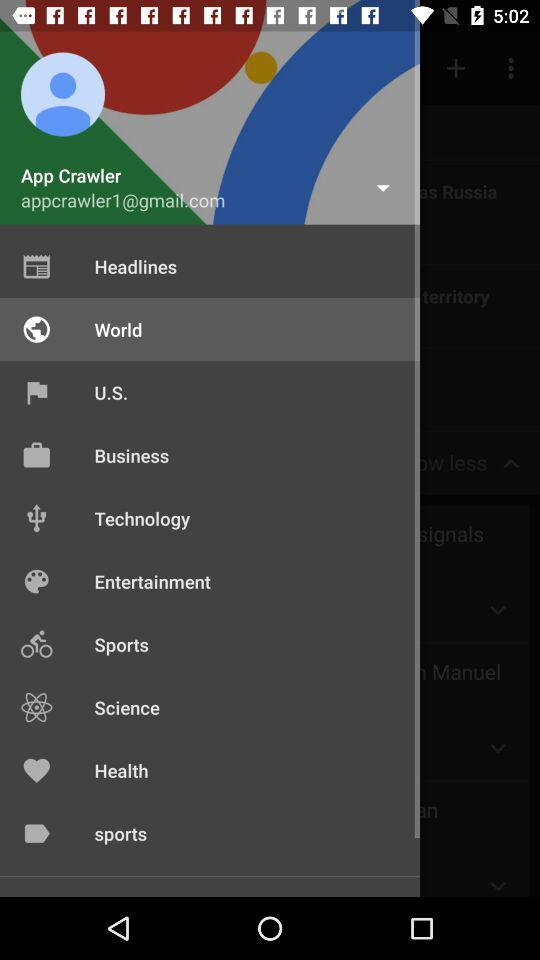What is the user name? The user name is App Crawler. 